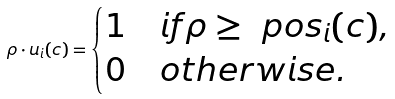Convert formula to latex. <formula><loc_0><loc_0><loc_500><loc_500>\rho \cdot u _ { i } ( c ) = \begin{cases} 1 & i f \rho \geq \ p o s _ { i } ( c ) , \\ 0 & o t h e r w i s e . \end{cases}</formula> 